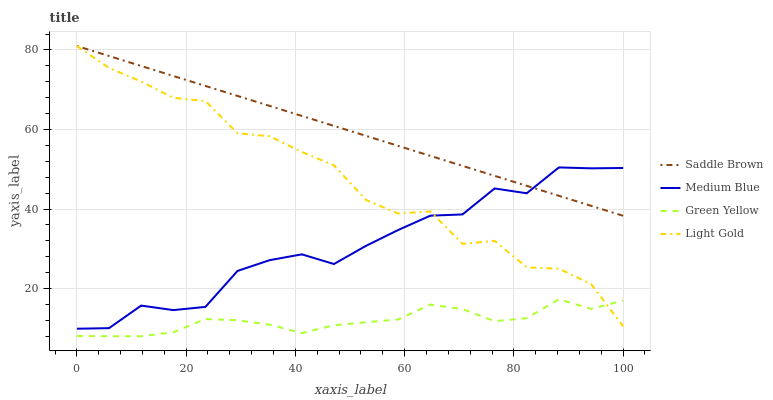Does Green Yellow have the minimum area under the curve?
Answer yes or no. Yes. Does Saddle Brown have the maximum area under the curve?
Answer yes or no. Yes. Does Medium Blue have the minimum area under the curve?
Answer yes or no. No. Does Medium Blue have the maximum area under the curve?
Answer yes or no. No. Is Saddle Brown the smoothest?
Answer yes or no. Yes. Is Light Gold the roughest?
Answer yes or no. Yes. Is Green Yellow the smoothest?
Answer yes or no. No. Is Green Yellow the roughest?
Answer yes or no. No. Does Medium Blue have the lowest value?
Answer yes or no. No. Does Saddle Brown have the highest value?
Answer yes or no. Yes. Does Medium Blue have the highest value?
Answer yes or no. No. Is Green Yellow less than Saddle Brown?
Answer yes or no. Yes. Is Medium Blue greater than Green Yellow?
Answer yes or no. Yes. Does Light Gold intersect Saddle Brown?
Answer yes or no. Yes. Is Light Gold less than Saddle Brown?
Answer yes or no. No. Is Light Gold greater than Saddle Brown?
Answer yes or no. No. Does Green Yellow intersect Saddle Brown?
Answer yes or no. No. 